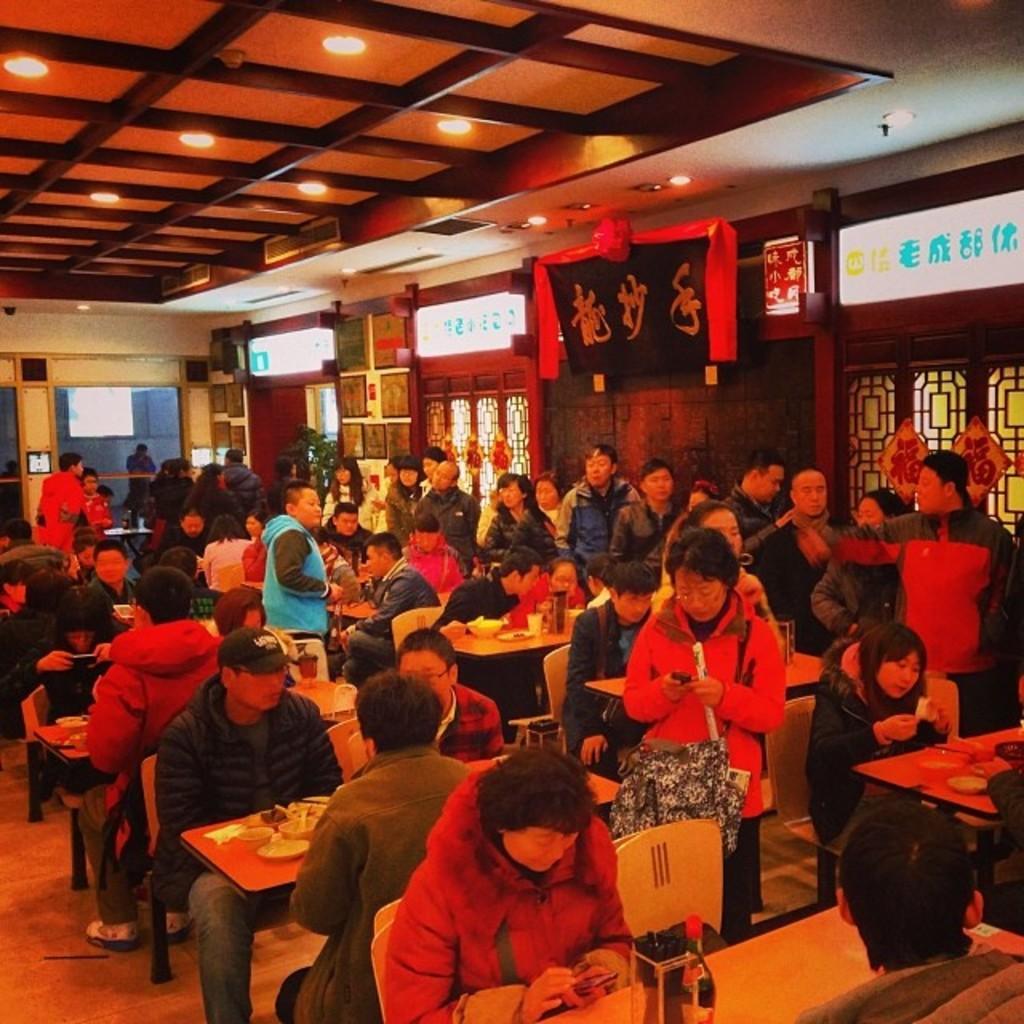How would you summarize this image in a sentence or two? Some people are sitting at a tables and some are standing in a restaurant. 